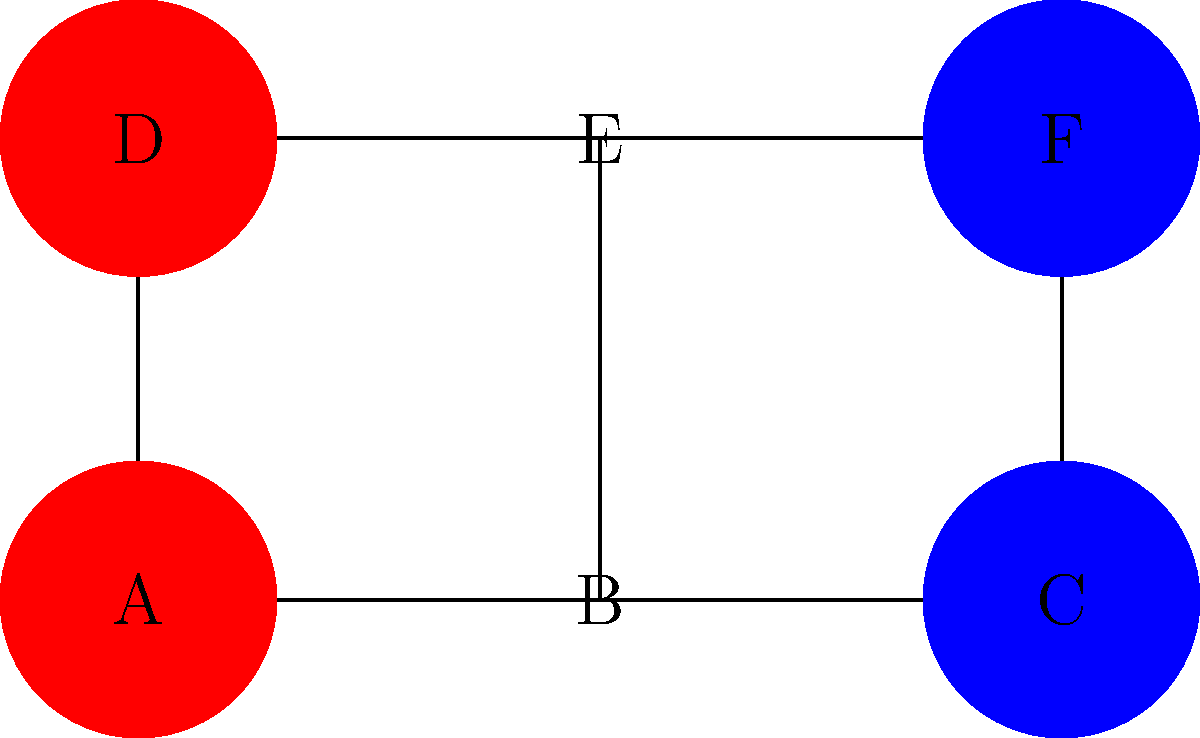In the diagram above, counties A, B, C, D, E, and F are represented. Red counties historically vote for Party X, while blue counties vote for Party Y. If a county's voting pattern is influenced by its adjacent counties, which single county, if it were to switch parties, would have the greatest potential to change the overall voting landscape of the region? To determine which county would have the greatest impact if it switched parties, we need to analyze the connectivity and current voting patterns:

1. County A: Connected to B, D, E. Currently red.
2. County B: Connected to A, C, E. Currently neutral.
3. County C: Connected to B, F. Currently blue.
4. County D: Connected to A, E. Currently red.
5. County E: Connected to A, B, D, F. Currently neutral.
6. County F: Connected to C, E. Currently blue.

Step 1: Identify the counties with the most connections.
- County E has the most connections (4), followed by counties A and B (3 each).

Step 2: Consider the current voting patterns.
- Counties A and D are red, C and F are blue, B and E are neutral.

Step 3: Analyze the potential impact of each county switching:
- If A switched to blue, it could influence B and D.
- If C switched to red, it could influence B and F.
- If D switched to blue, it could influence A.
- If F switched to red, it could influence C.
- If B switched to either red or blue, it could influence A, C, and E.
- If E switched to either red or blue, it could influence A, B, D, and F.

Step 4: Determine the county with the greatest potential impact.
County E has the most connections and is currently neutral. If it were to switch to either party, it could potentially influence the most adjacent counties, including both red and blue counties.
Answer: County E 